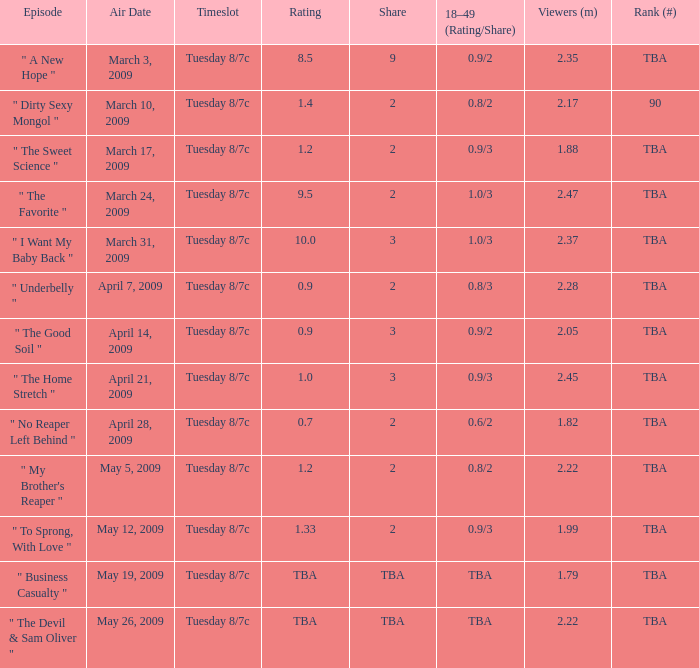What is the timeslot for the episode that aired April 28, 2009? Tuesday 8/7c. 